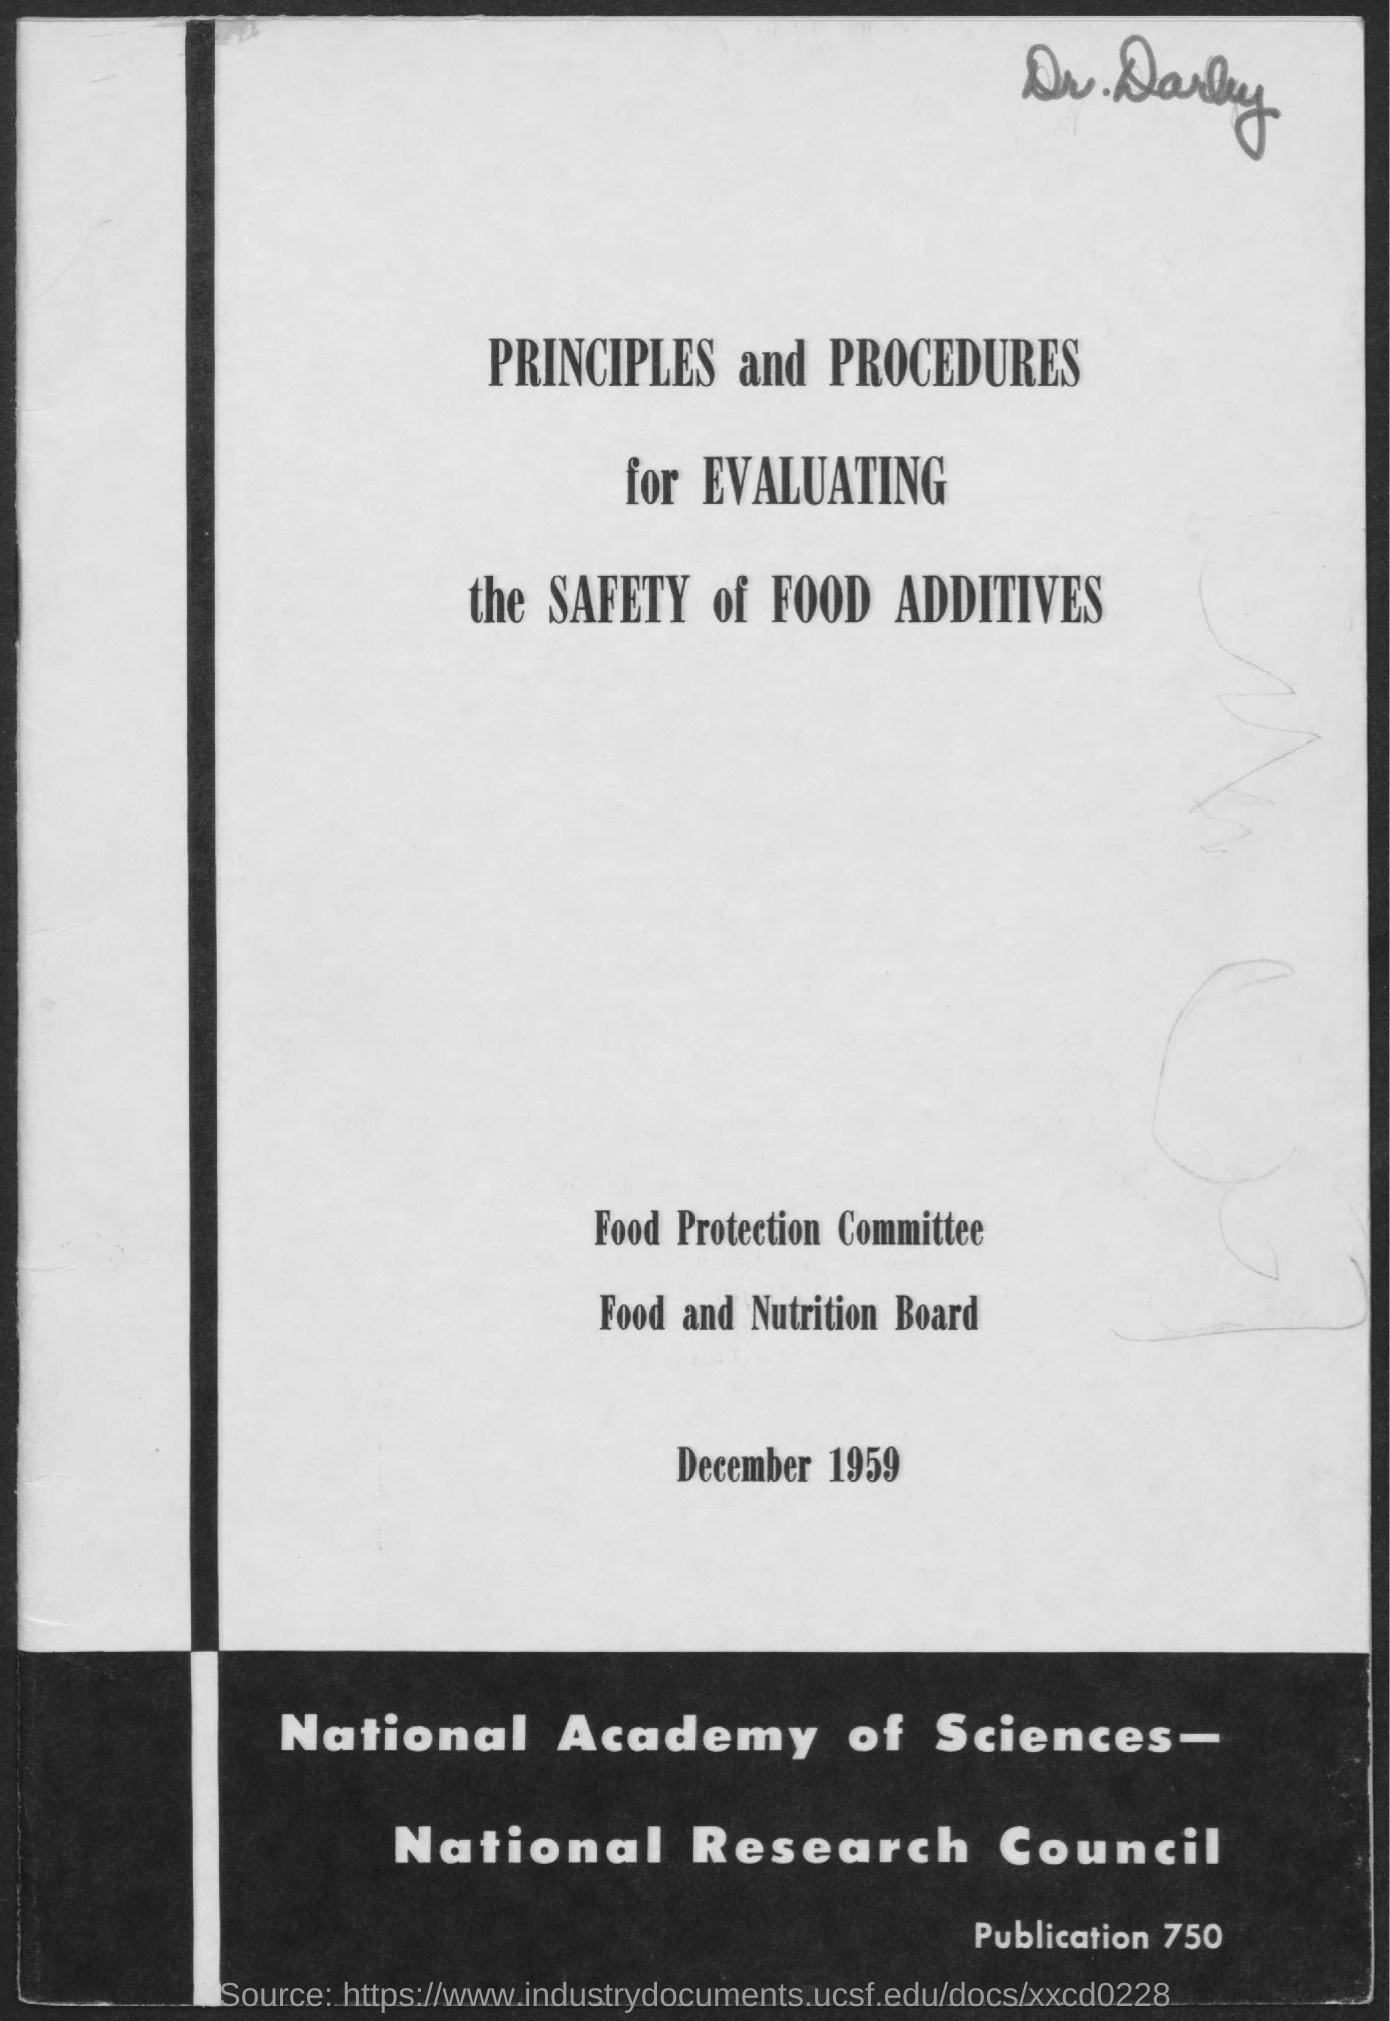What is the date mentioned in the document?
Offer a terse response. December 1959. What is the name of the committee mentioned in the document?
Your response must be concise. Food Protection Committee. What is the name of the doctor written at the top right of the document?
Offer a very short reply. Dr.Darby. 